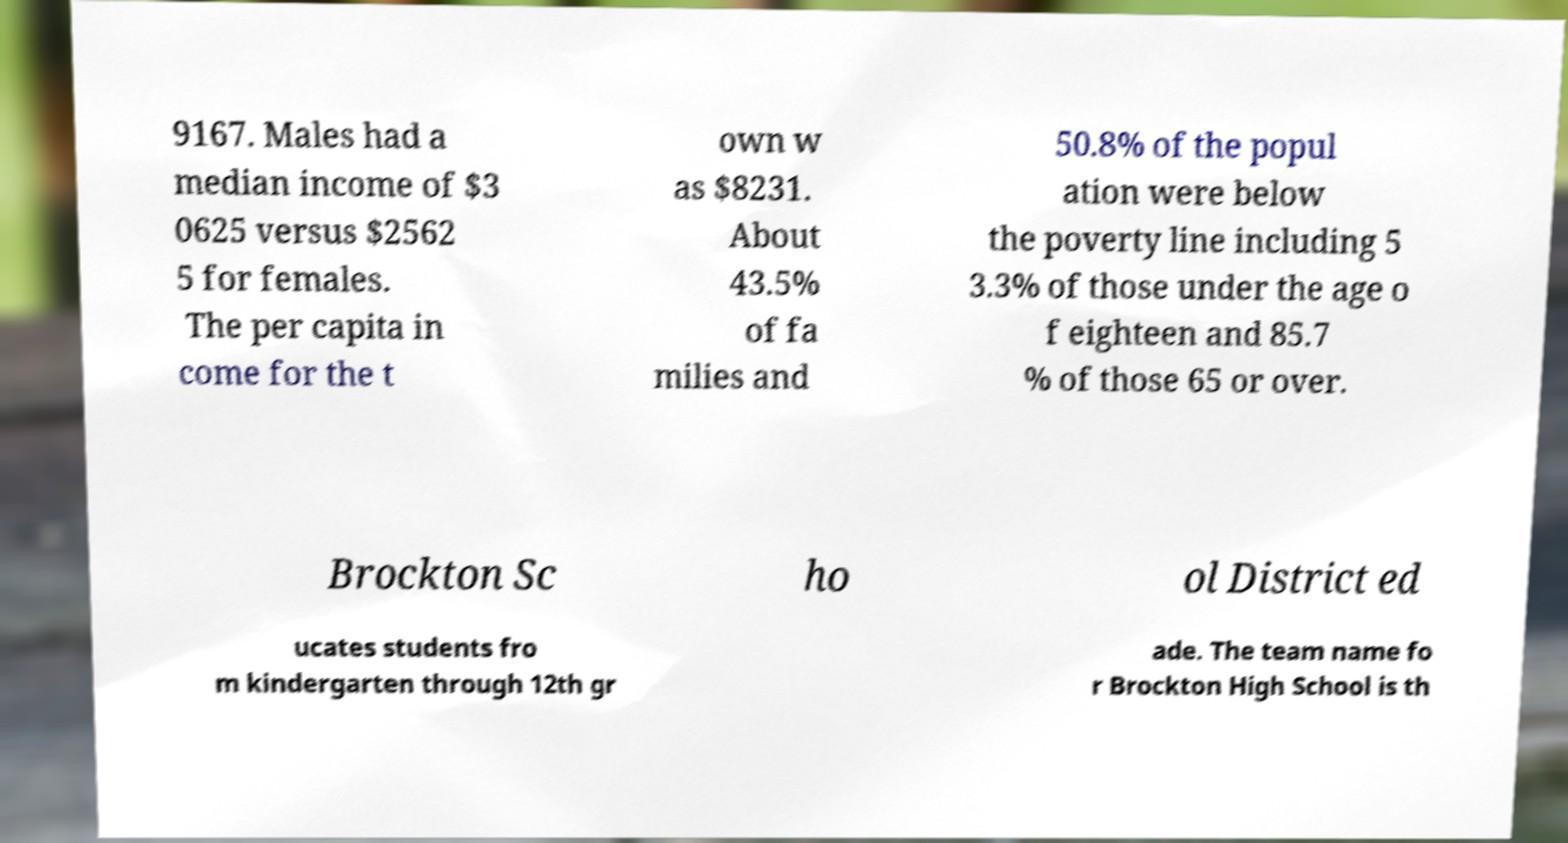What messages or text are displayed in this image? I need them in a readable, typed format. 9167. Males had a median income of $3 0625 versus $2562 5 for females. The per capita in come for the t own w as $8231. About 43.5% of fa milies and 50.8% of the popul ation were below the poverty line including 5 3.3% of those under the age o f eighteen and 85.7 % of those 65 or over. Brockton Sc ho ol District ed ucates students fro m kindergarten through 12th gr ade. The team name fo r Brockton High School is th 